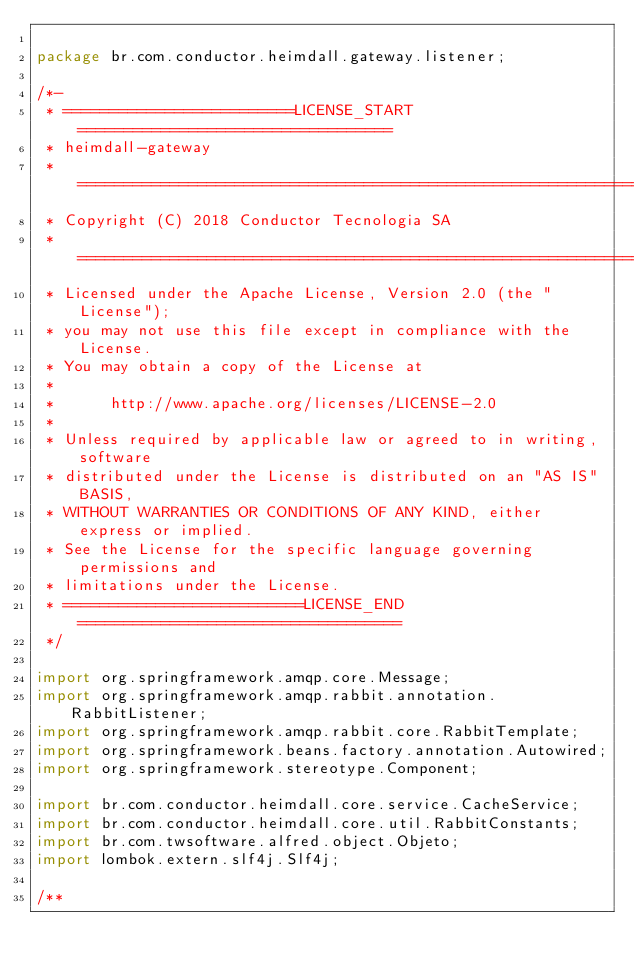<code> <loc_0><loc_0><loc_500><loc_500><_Java_>
package br.com.conductor.heimdall.gateway.listener;

/*-
 * =========================LICENSE_START==================================
 * heimdall-gateway
 * ========================================================================
 * Copyright (C) 2018 Conductor Tecnologia SA
 * ========================================================================
 * Licensed under the Apache License, Version 2.0 (the "License");
 * you may not use this file except in compliance with the License.
 * You may obtain a copy of the License at
 * 
 *      http://www.apache.org/licenses/LICENSE-2.0
 * 
 * Unless required by applicable law or agreed to in writing, software
 * distributed under the License is distributed on an "AS IS" BASIS,
 * WITHOUT WARRANTIES OR CONDITIONS OF ANY KIND, either express or implied.
 * See the License for the specific language governing permissions and
 * limitations under the License.
 * ==========================LICENSE_END===================================
 */

import org.springframework.amqp.core.Message;
import org.springframework.amqp.rabbit.annotation.RabbitListener;
import org.springframework.amqp.rabbit.core.RabbitTemplate;
import org.springframework.beans.factory.annotation.Autowired;
import org.springframework.stereotype.Component;

import br.com.conductor.heimdall.core.service.CacheService;
import br.com.conductor.heimdall.core.util.RabbitConstants;
import br.com.twsoftware.alfred.object.Objeto;
import lombok.extern.slf4j.Slf4j;

/**</code> 